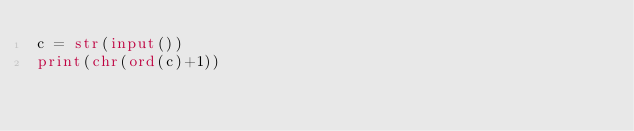<code> <loc_0><loc_0><loc_500><loc_500><_Python_>c = str(input())
print(chr(ord(c)+1))
</code> 